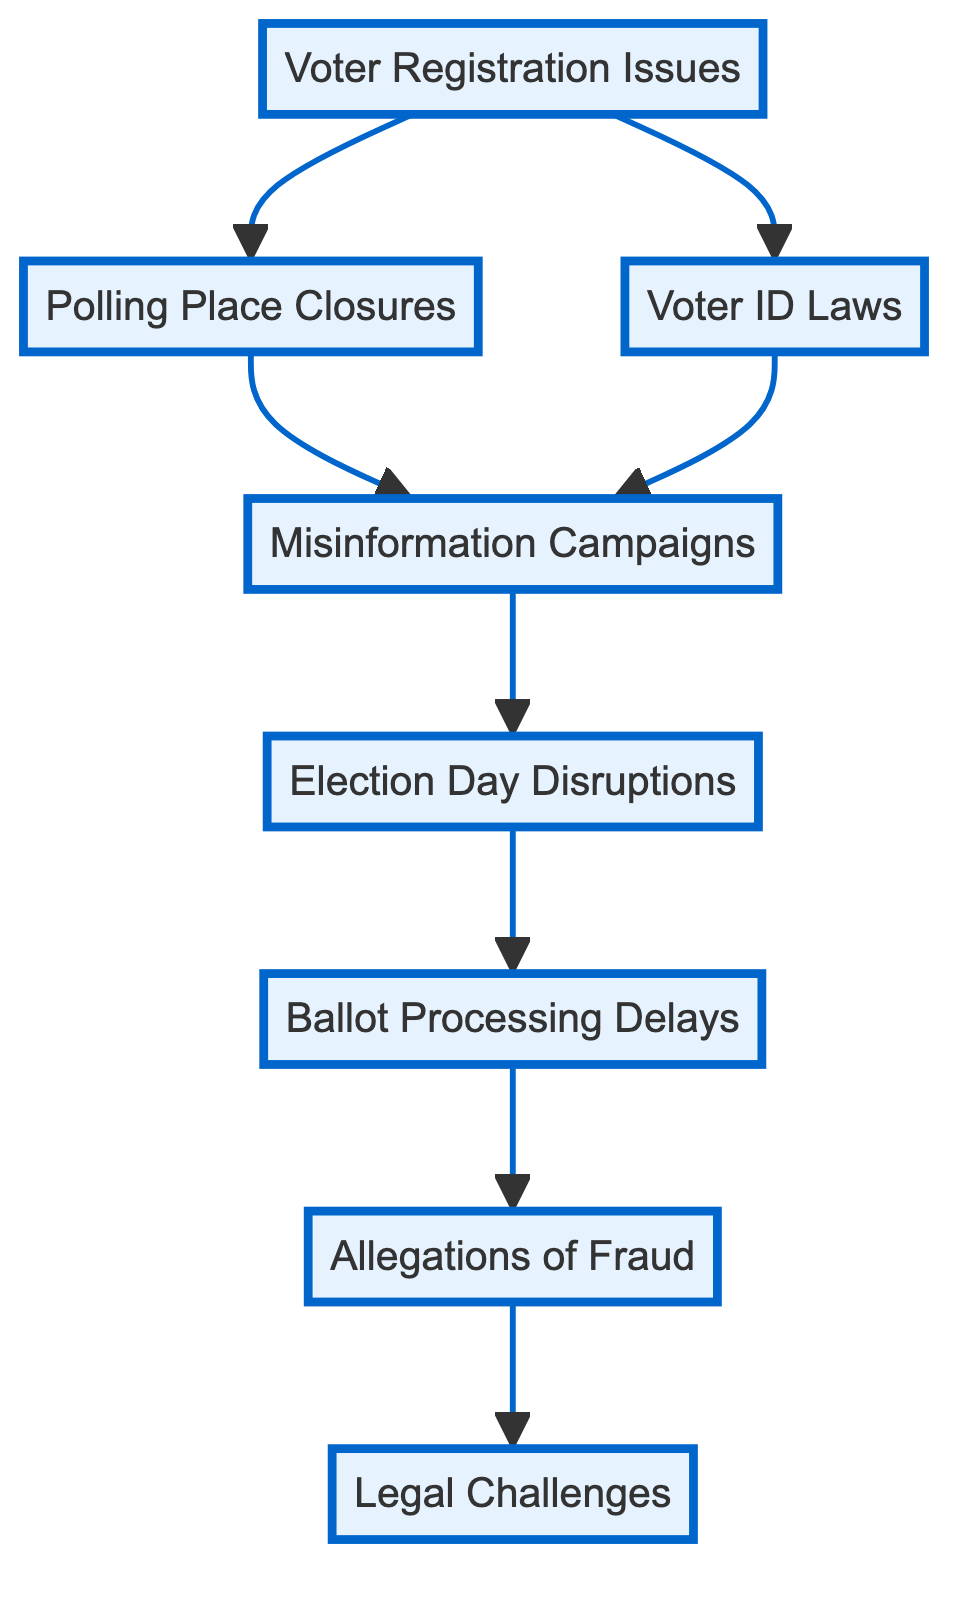What is the first event in the chain? The first event in the chain is "Voter Registration Issues." It is represented as the starting point of the flow diagram and is the first node listed.
Answer: Voter Registration Issues How many total events are shown in the diagram? The diagram contains eight distinct events that are all linked together. Counting the nodes yields a total of eight events.
Answer: 8 What is the last event in the chain? The last event in the chain is "Legal Challenges." It is the endpoint of the flow diagram, following the final event, "Allegations of Fraud."
Answer: Legal Challenges Which events directly lead to allegations of fraud? The events "Ballot Processing Delays" and "Allegations of Fraud" are the two nodes that directly connect before reaching "Legal Challenges" at the end of the flow.
Answer: Ballot Processing Delays How many connections lead from "Voter ID Laws"? "Voter ID Laws" has two outgoing connections, leading to "Misinformation Campaigns" and "Polling Place Closures."
Answer: 2 What type of disruptions are reported on Election Day? The event "Election Day Disruptions" describes reports of harassment and intimidation at polling stations on election day. This is detailed in the node description.
Answer: Election Day Disruptions Which event is affected by both "Polling Place Closures" and "Voter ID Laws"? Both "Polling Place Closures" and "Voter ID Laws" influence the event "Misinformation Campaigns," which arises as a result of both issues.
Answer: Misinformation Campaigns Which event has the most subsequent nodes connected to it? "Ballot Processing Delays" leads to "Allegations of Fraud," indicating that it acts as a significant transition point to later events. It has one outgoing node connected to it.
Answer: 1 